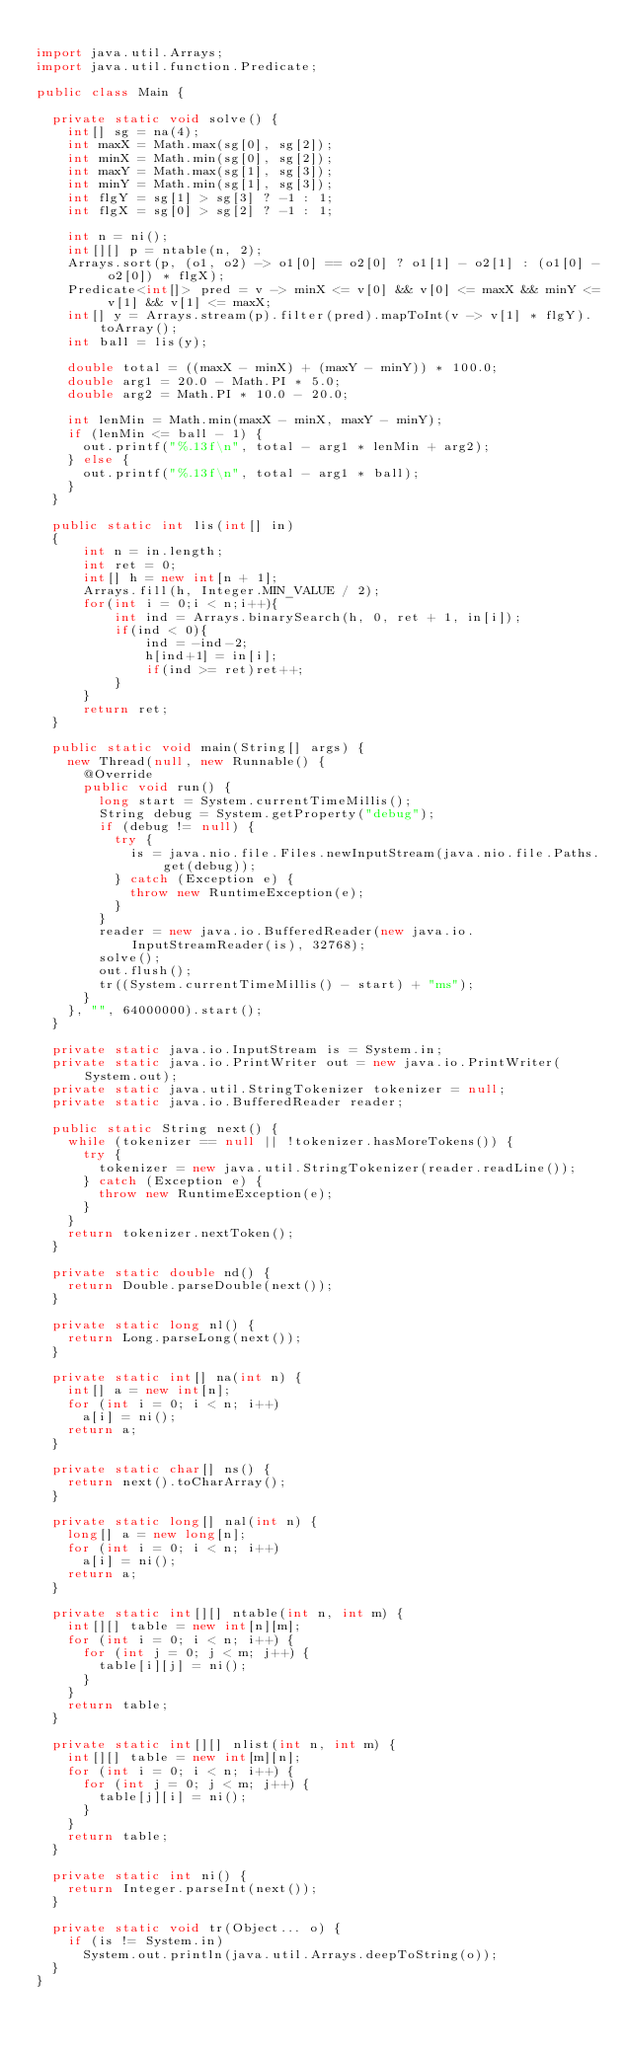<code> <loc_0><loc_0><loc_500><loc_500><_Java_>
import java.util.Arrays;
import java.util.function.Predicate;

public class Main {

  private static void solve() {
    int[] sg = na(4);
    int maxX = Math.max(sg[0], sg[2]);
    int minX = Math.min(sg[0], sg[2]);
    int maxY = Math.max(sg[1], sg[3]);
    int minY = Math.min(sg[1], sg[3]);
    int flgY = sg[1] > sg[3] ? -1 : 1;
    int flgX = sg[0] > sg[2] ? -1 : 1;

    int n = ni();
    int[][] p = ntable(n, 2);
    Arrays.sort(p, (o1, o2) -> o1[0] == o2[0] ? o1[1] - o2[1] : (o1[0] - o2[0]) * flgX);
    Predicate<int[]> pred = v -> minX <= v[0] && v[0] <= maxX && minY <= v[1] && v[1] <= maxX;
    int[] y = Arrays.stream(p).filter(pred).mapToInt(v -> v[1] * flgY).toArray();
    int ball = lis(y);

    double total = ((maxX - minX) + (maxY - minY)) * 100.0;
    double arg1 = 20.0 - Math.PI * 5.0;
    double arg2 = Math.PI * 10.0 - 20.0;

    int lenMin = Math.min(maxX - minX, maxY - minY);
    if (lenMin <= ball - 1) {
      out.printf("%.13f\n", total - arg1 * lenMin + arg2);
    } else {
      out.printf("%.13f\n", total - arg1 * ball);
    }
  }
  
  public static int lis(int[] in)
  {
      int n = in.length;
      int ret = 0;
      int[] h = new int[n + 1];
      Arrays.fill(h, Integer.MIN_VALUE / 2);
      for(int i = 0;i < n;i++){
          int ind = Arrays.binarySearch(h, 0, ret + 1, in[i]);
          if(ind < 0){
              ind = -ind-2;
              h[ind+1] = in[i];
              if(ind >= ret)ret++;
          }
      }
      return ret;
  }

  public static void main(String[] args) {
    new Thread(null, new Runnable() {
      @Override
      public void run() {
        long start = System.currentTimeMillis();
        String debug = System.getProperty("debug");
        if (debug != null) {
          try {
            is = java.nio.file.Files.newInputStream(java.nio.file.Paths.get(debug));
          } catch (Exception e) {
            throw new RuntimeException(e);
          }
        }
        reader = new java.io.BufferedReader(new java.io.InputStreamReader(is), 32768);
        solve();
        out.flush();
        tr((System.currentTimeMillis() - start) + "ms");
      }
    }, "", 64000000).start();
  }

  private static java.io.InputStream is = System.in;
  private static java.io.PrintWriter out = new java.io.PrintWriter(System.out);
  private static java.util.StringTokenizer tokenizer = null;
  private static java.io.BufferedReader reader;

  public static String next() {
    while (tokenizer == null || !tokenizer.hasMoreTokens()) {
      try {
        tokenizer = new java.util.StringTokenizer(reader.readLine());
      } catch (Exception e) {
        throw new RuntimeException(e);
      }
    }
    return tokenizer.nextToken();
  }

  private static double nd() {
    return Double.parseDouble(next());
  }

  private static long nl() {
    return Long.parseLong(next());
  }

  private static int[] na(int n) {
    int[] a = new int[n];
    for (int i = 0; i < n; i++)
      a[i] = ni();
    return a;
  }

  private static char[] ns() {
    return next().toCharArray();
  }

  private static long[] nal(int n) {
    long[] a = new long[n];
    for (int i = 0; i < n; i++)
      a[i] = ni();
    return a;
  }

  private static int[][] ntable(int n, int m) {
    int[][] table = new int[n][m];
    for (int i = 0; i < n; i++) {
      for (int j = 0; j < m; j++) {
        table[i][j] = ni();
      }
    }
    return table;
  }

  private static int[][] nlist(int n, int m) {
    int[][] table = new int[m][n];
    for (int i = 0; i < n; i++) {
      for (int j = 0; j < m; j++) {
        table[j][i] = ni();
      }
    }
    return table;
  }

  private static int ni() {
    return Integer.parseInt(next());
  }

  private static void tr(Object... o) {
    if (is != System.in)
      System.out.println(java.util.Arrays.deepToString(o));
  }
}




</code> 